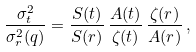Convert formula to latex. <formula><loc_0><loc_0><loc_500><loc_500>\frac { \sigma ^ { 2 } _ { t } } { \sigma ^ { 2 } _ { r } ( q ) } = \frac { S ( t ) } { S ( r ) } \, \frac { A ( t ) } { \zeta ( t ) } \, \frac { \zeta ( r ) } { A ( r ) } \, ,</formula> 